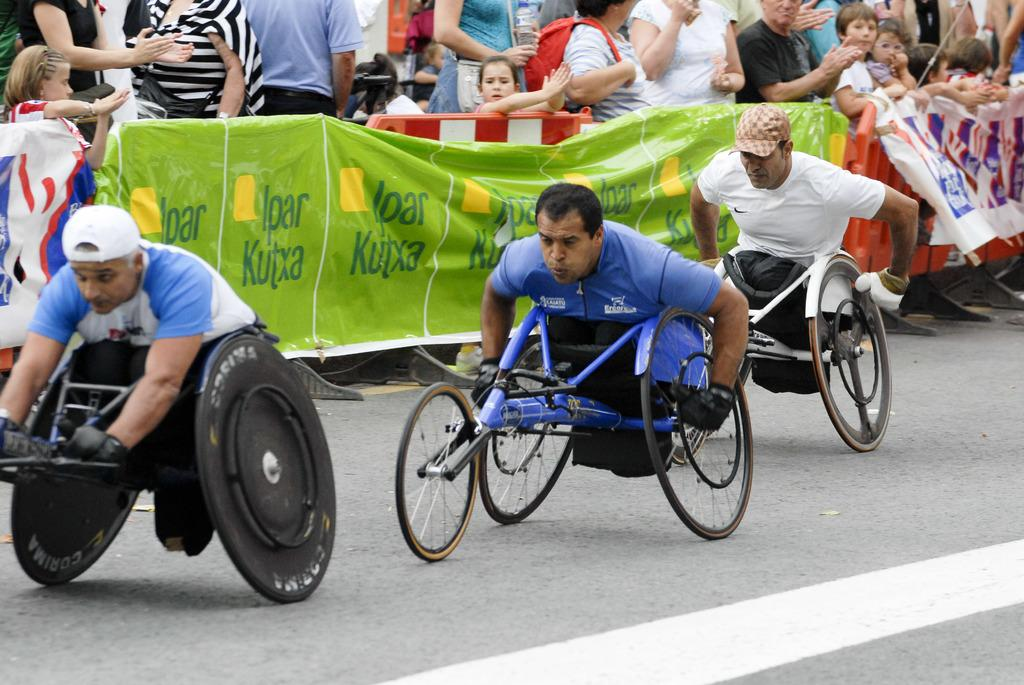What activity are the three persons in the image participating in? The three persons are participating in a wheelchair racing. What additional elements can be seen in the image? There are banners and barriers in the image. Can you describe the people in the background of the image? There is a group of people in the background of the image. What type of ghost can be seen interacting with the wheelchair racers in the image? There is no ghost present in the image; it features three persons participating in a wheelchair racing with banners and barriers. 